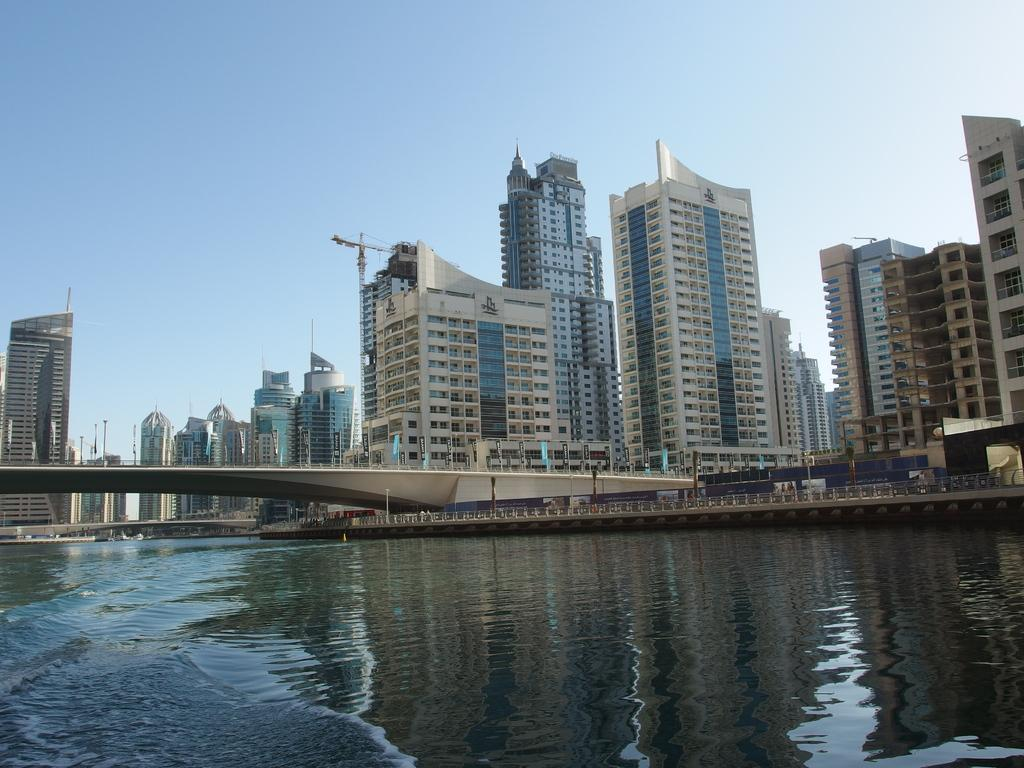What type of structures can be seen in the image? There are buildings in the image. What natural element is visible in the image? Water is visible in the image. What connects the two sides of the water in the image? There is a bridge in the image. What month is the family celebrating in the image? There is no family present in the image, and therefore no celebration or month can be determined. Who is the manager of the bridge in the image? There is no manager mentioned or depicted in the image. 